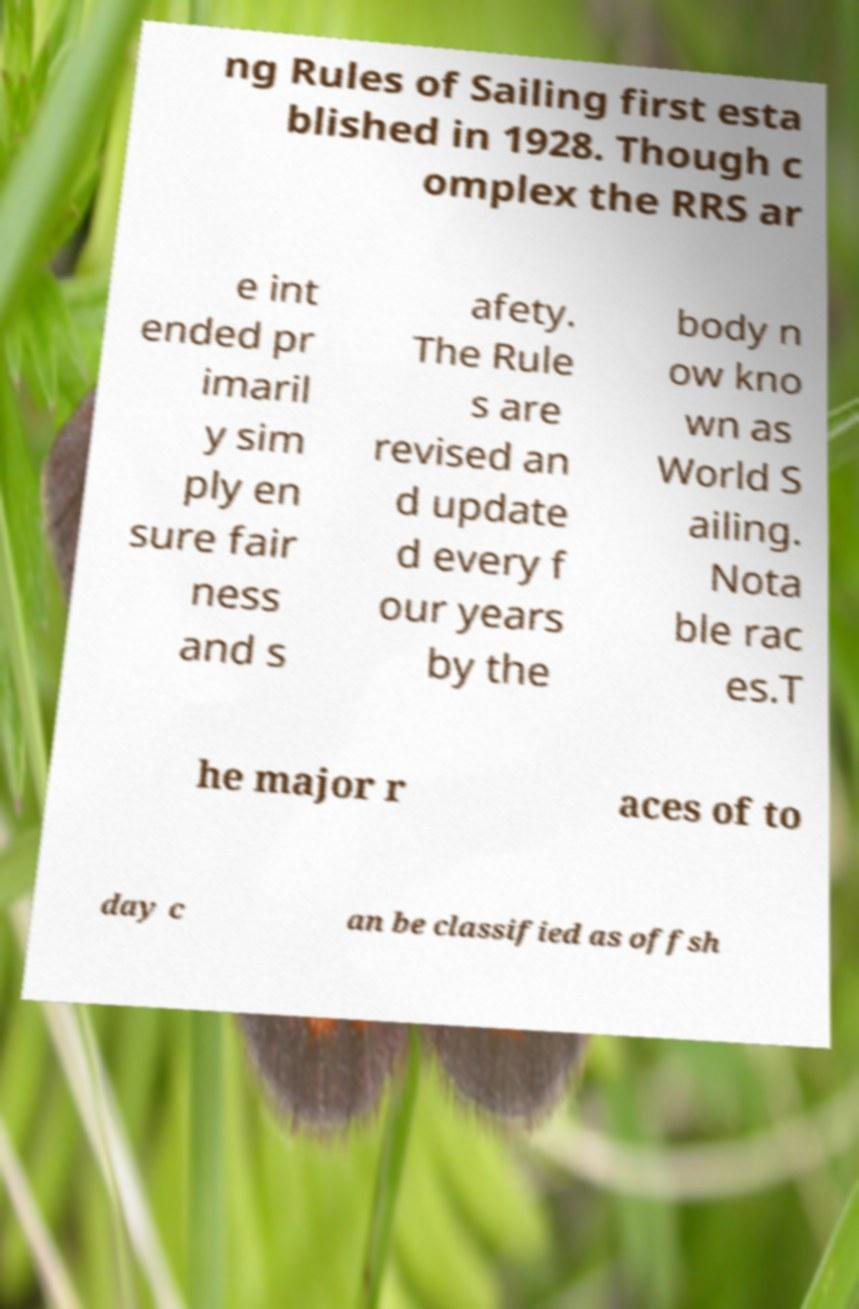Can you accurately transcribe the text from the provided image for me? ng Rules of Sailing first esta blished in 1928. Though c omplex the RRS ar e int ended pr imaril y sim ply en sure fair ness and s afety. The Rule s are revised an d update d every f our years by the body n ow kno wn as World S ailing. Nota ble rac es.T he major r aces of to day c an be classified as offsh 